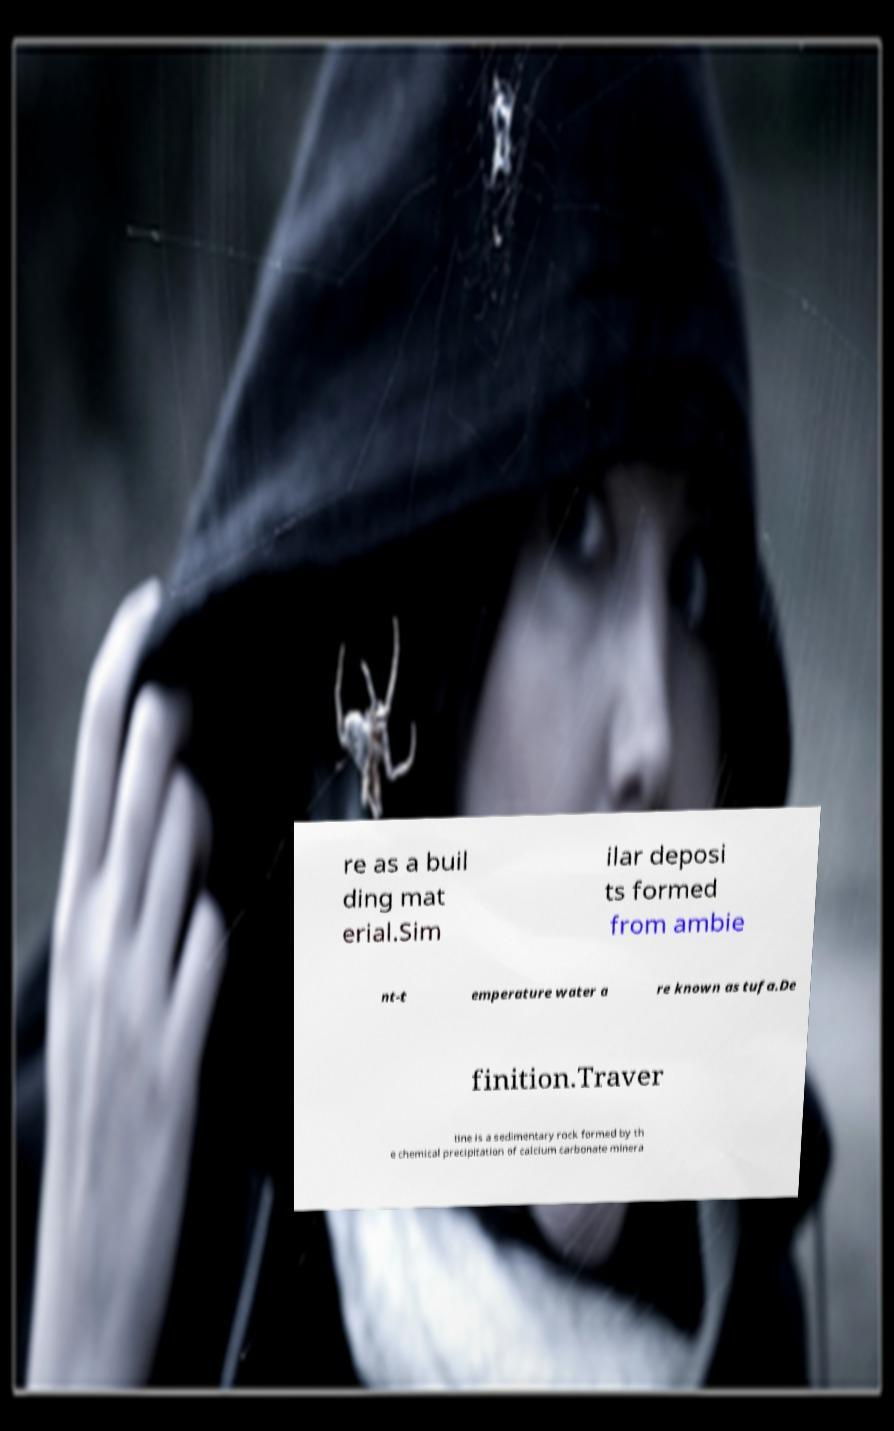Could you assist in decoding the text presented in this image and type it out clearly? re as a buil ding mat erial.Sim ilar deposi ts formed from ambie nt-t emperature water a re known as tufa.De finition.Traver tine is a sedimentary rock formed by th e chemical precipitation of calcium carbonate minera 